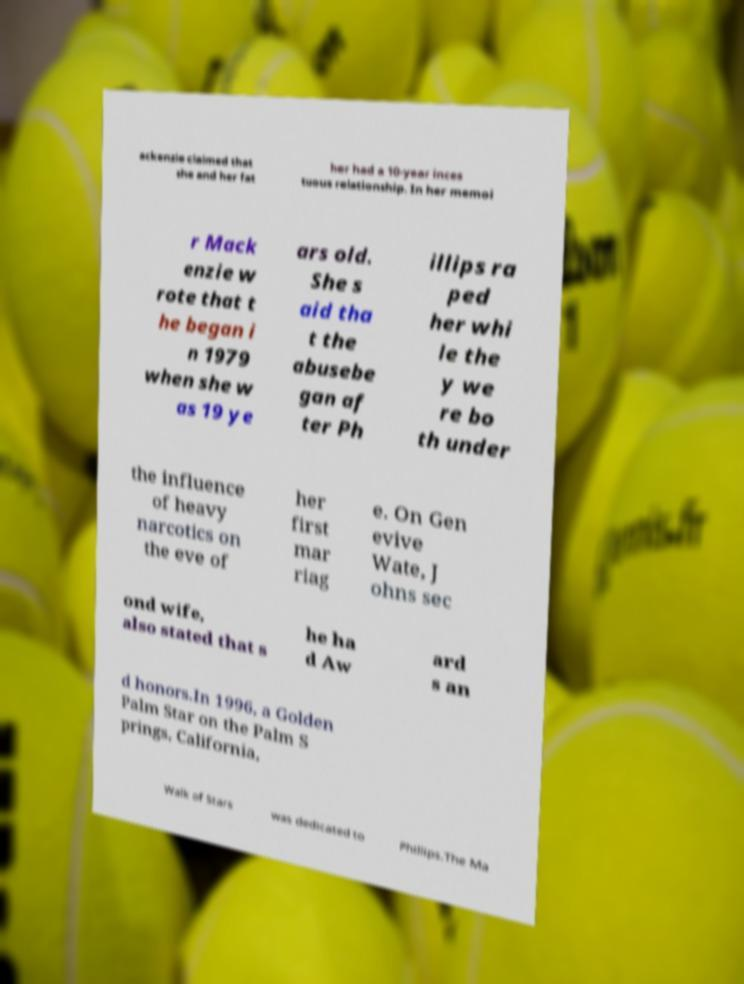Could you extract and type out the text from this image? ackenzie claimed that she and her fat her had a 10-year inces tuous relationship. In her memoi r Mack enzie w rote that t he began i n 1979 when she w as 19 ye ars old. She s aid tha t the abusebe gan af ter Ph illips ra ped her whi le the y we re bo th under the influence of heavy narcotics on the eve of her first mar riag e. On Gen evive Wate, J ohns sec ond wife, also stated that s he ha d Aw ard s an d honors.In 1996, a Golden Palm Star on the Palm S prings, California, Walk of Stars was dedicated to Phillips.The Ma 